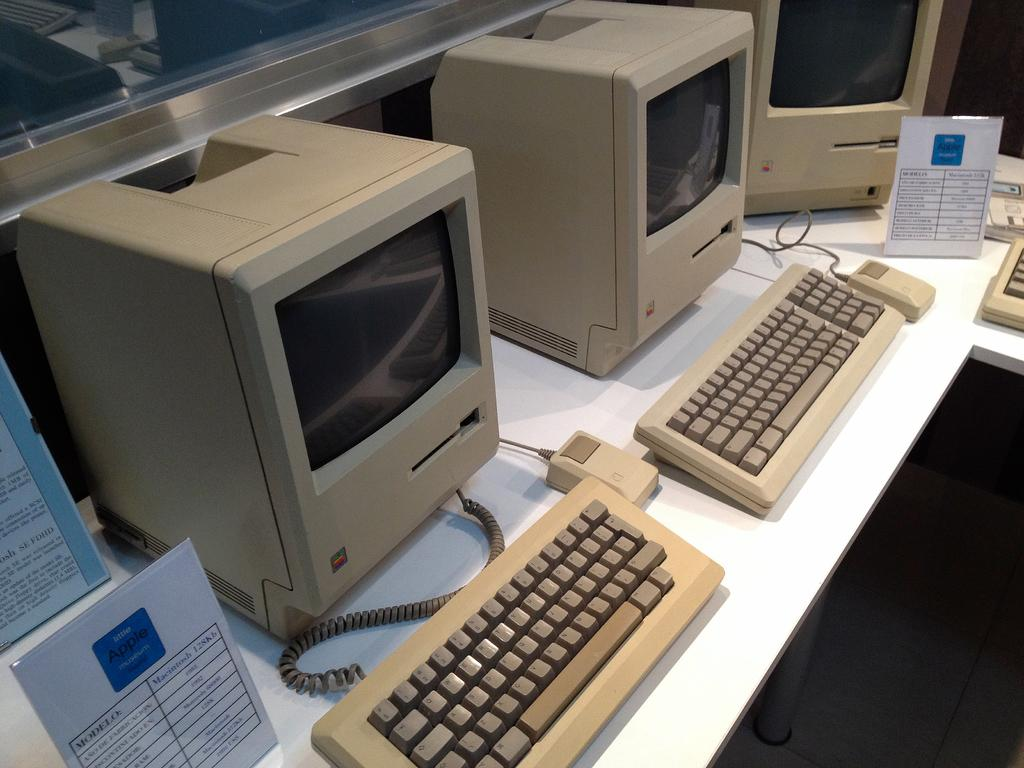<image>
Provide a brief description of the given image. A table of Machintosh 128kb computers on a white base 